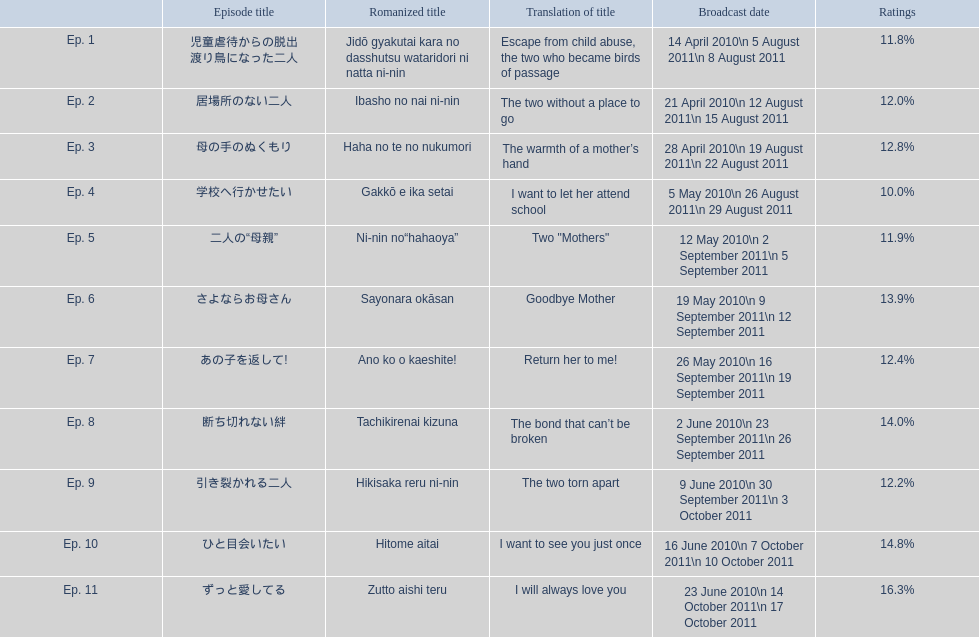How many episodes haven't surpassed 14%? 8. 